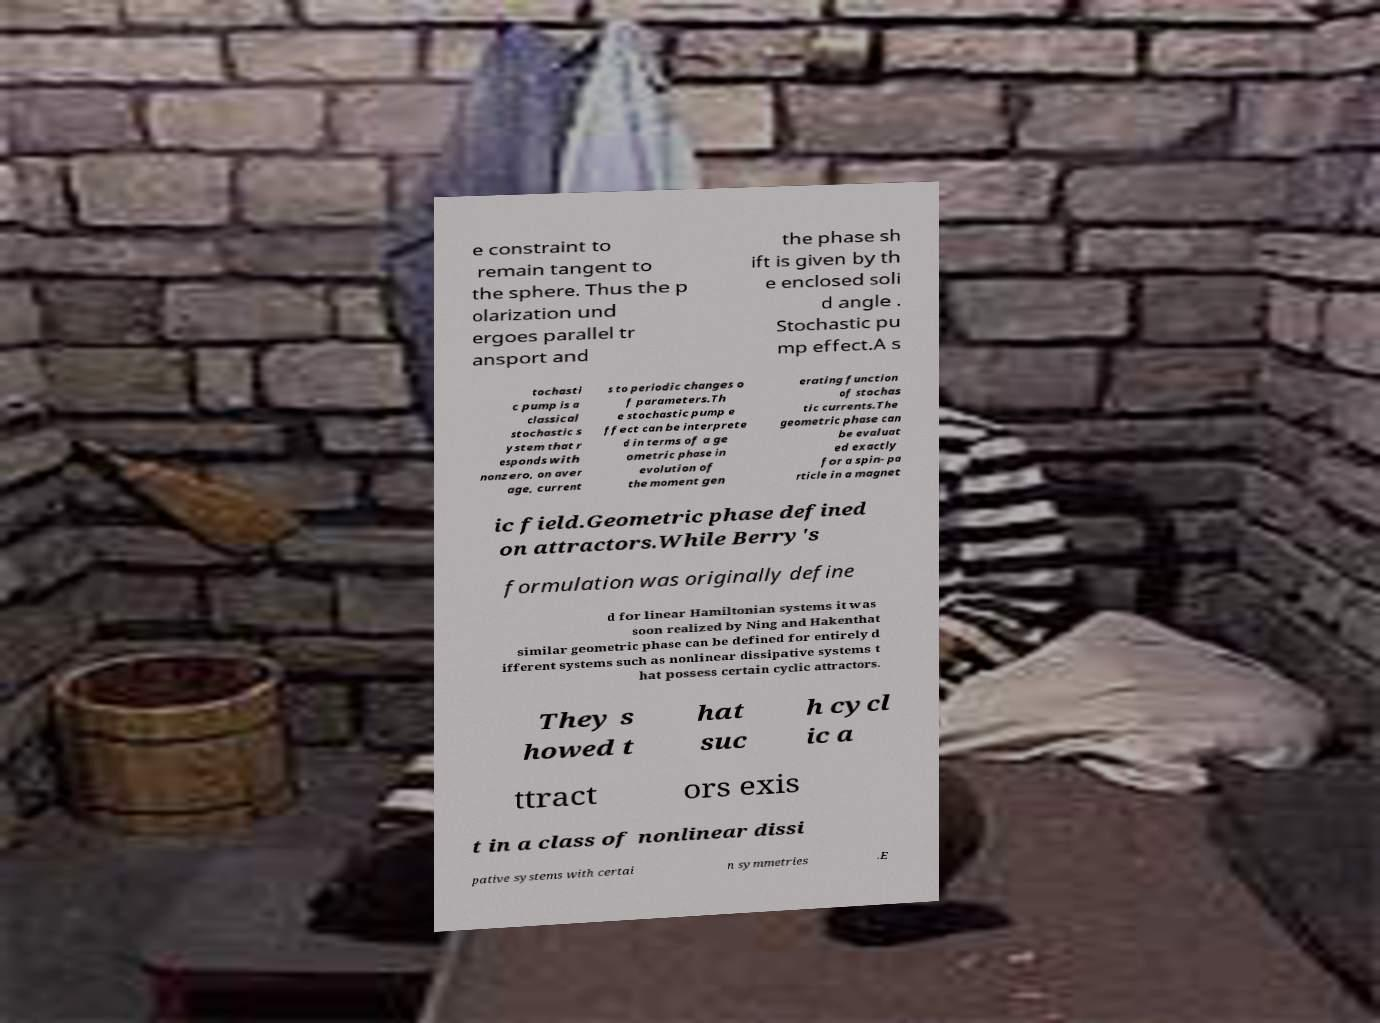What messages or text are displayed in this image? I need them in a readable, typed format. e constraint to remain tangent to the sphere. Thus the p olarization und ergoes parallel tr ansport and the phase sh ift is given by th e enclosed soli d angle . Stochastic pu mp effect.A s tochasti c pump is a classical stochastic s ystem that r esponds with nonzero, on aver age, current s to periodic changes o f parameters.Th e stochastic pump e ffect can be interprete d in terms of a ge ometric phase in evolution of the moment gen erating function of stochas tic currents.The geometric phase can be evaluat ed exactly for a spin- pa rticle in a magnet ic field.Geometric phase defined on attractors.While Berry's formulation was originally define d for linear Hamiltonian systems it was soon realized by Ning and Hakenthat similar geometric phase can be defined for entirely d ifferent systems such as nonlinear dissipative systems t hat possess certain cyclic attractors. They s howed t hat suc h cycl ic a ttract ors exis t in a class of nonlinear dissi pative systems with certai n symmetries .E 